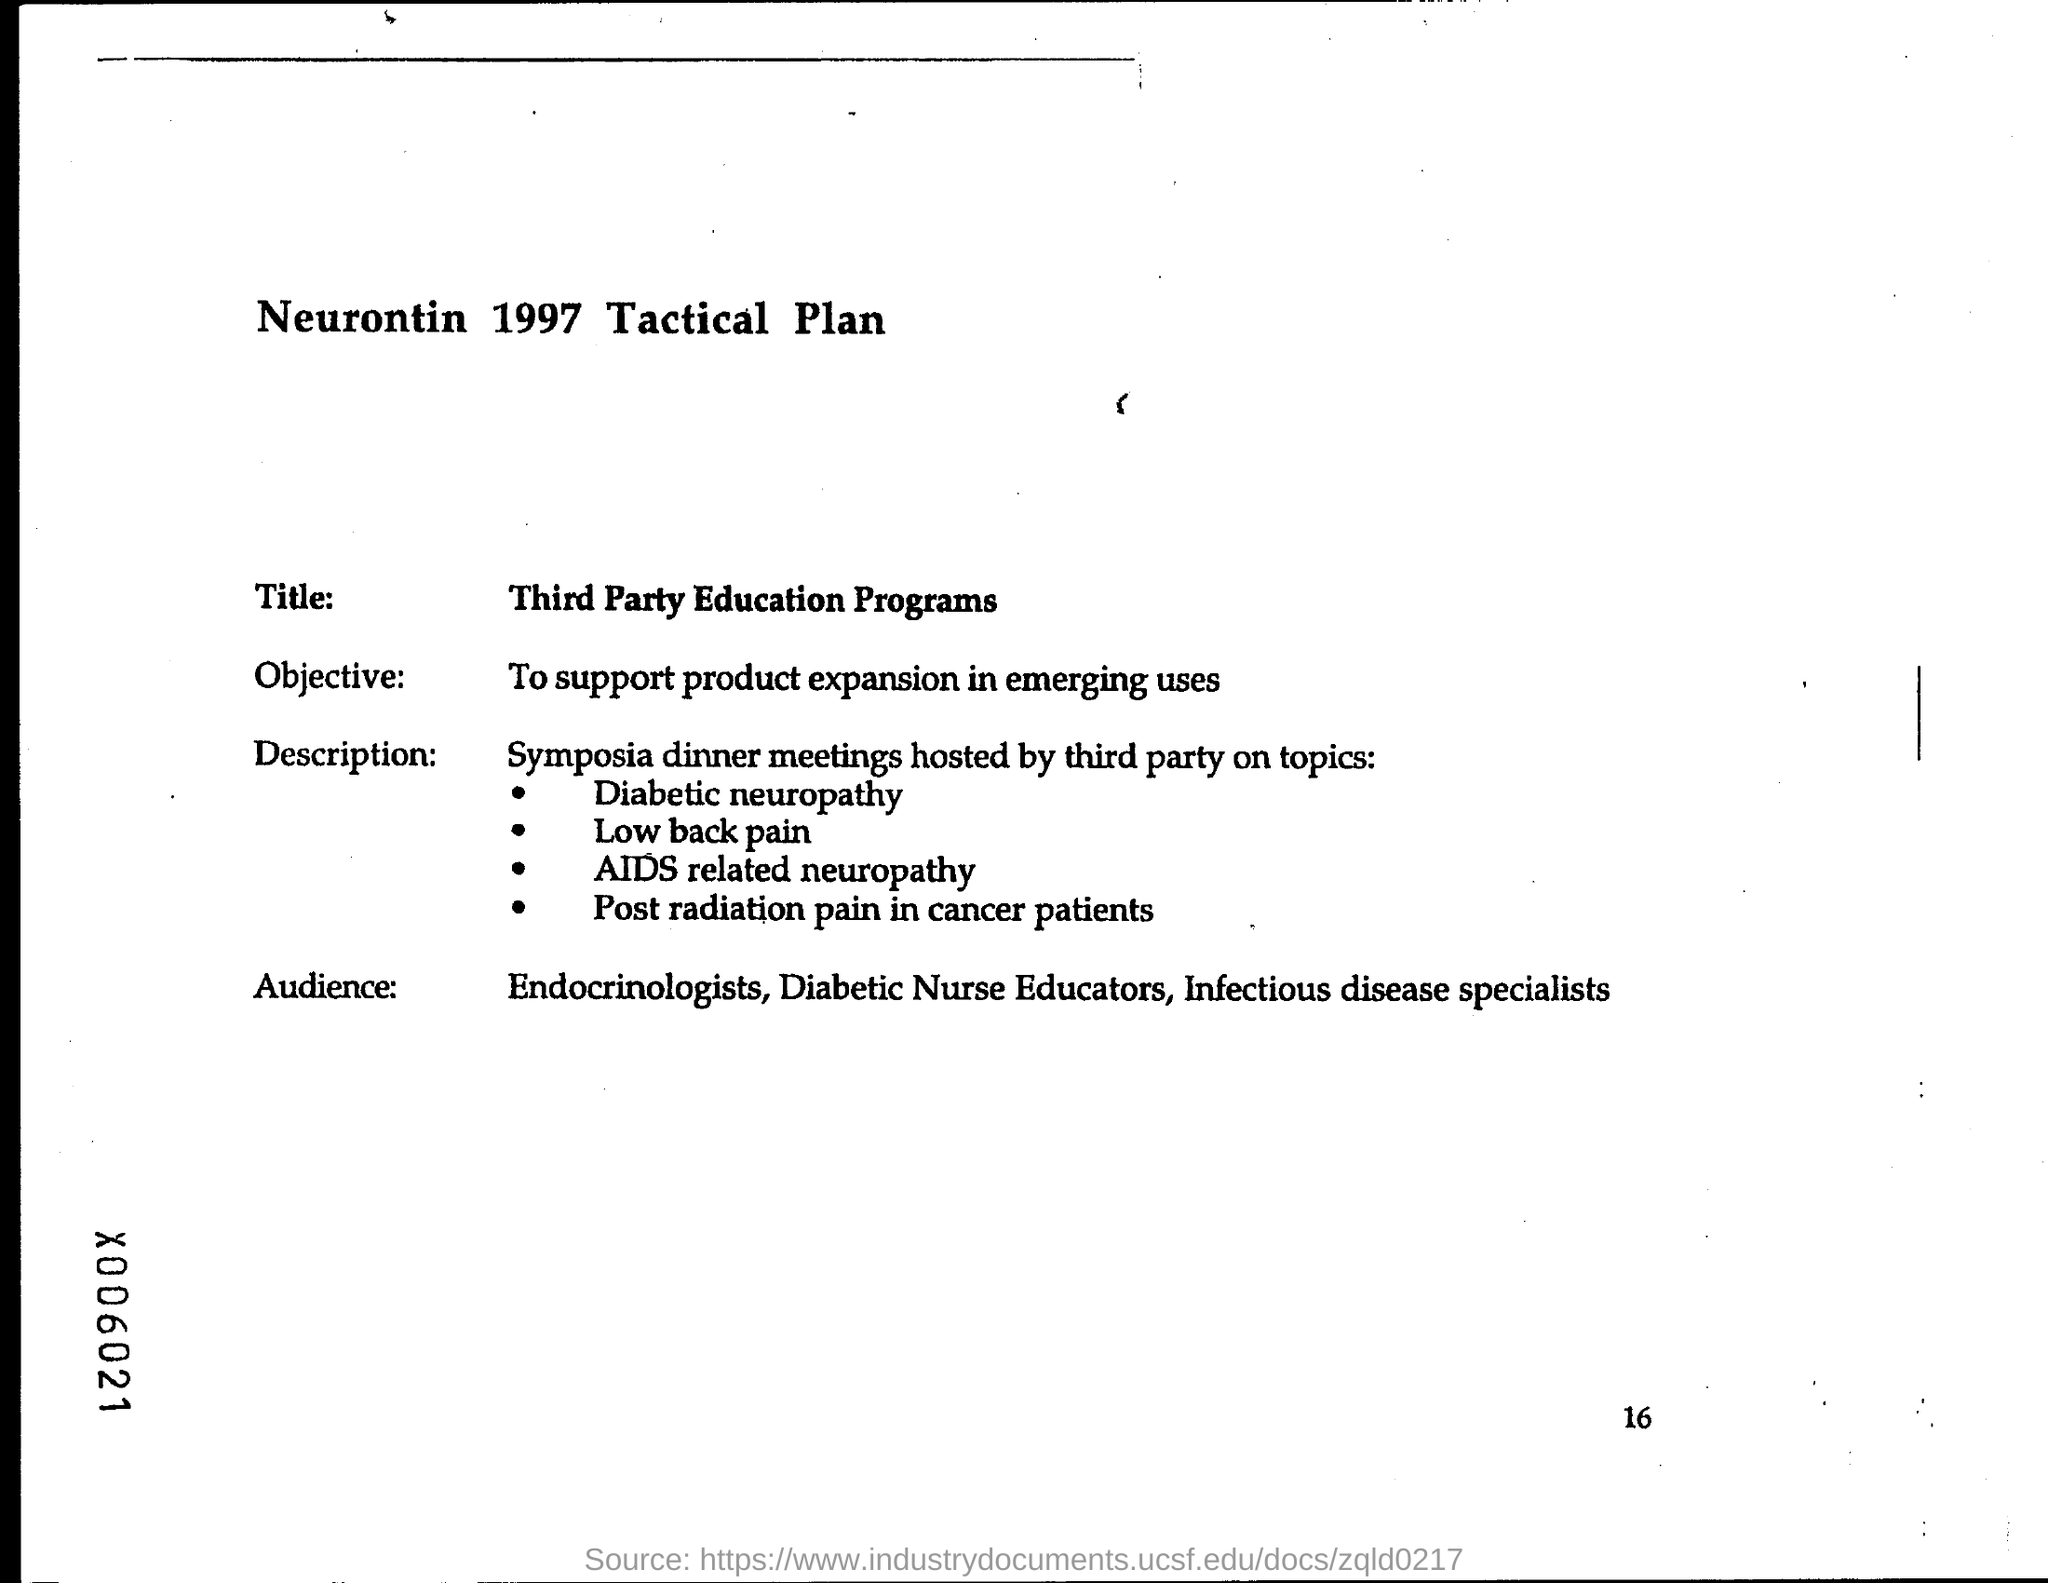Outline some significant characteristics in this image. The objective of the programs is to support product expansion in emerging uses. 